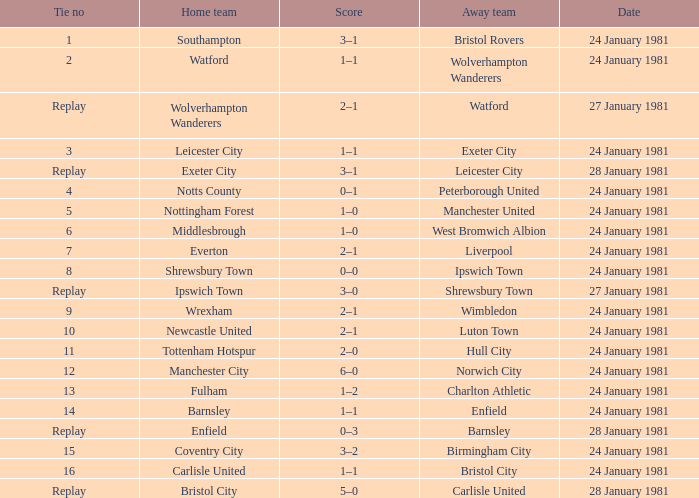What is the score when the stalemate is 8? 0–0. 